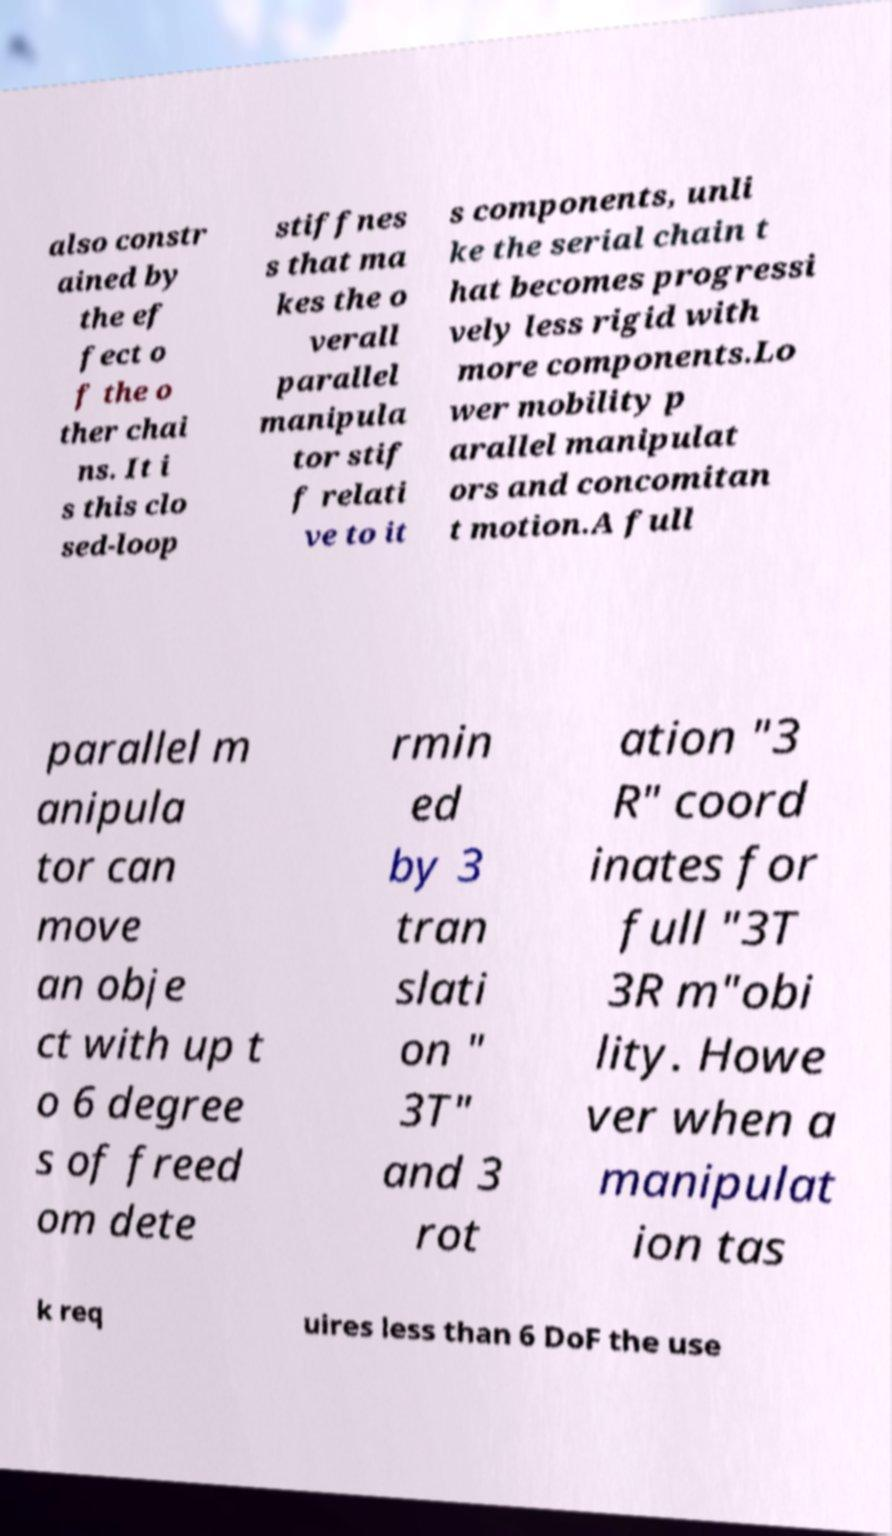Can you read and provide the text displayed in the image?This photo seems to have some interesting text. Can you extract and type it out for me? also constr ained by the ef fect o f the o ther chai ns. It i s this clo sed-loop stiffnes s that ma kes the o verall parallel manipula tor stif f relati ve to it s components, unli ke the serial chain t hat becomes progressi vely less rigid with more components.Lo wer mobility p arallel manipulat ors and concomitan t motion.A full parallel m anipula tor can move an obje ct with up t o 6 degree s of freed om dete rmin ed by 3 tran slati on " 3T" and 3 rot ation "3 R" coord inates for full "3T 3R m"obi lity. Howe ver when a manipulat ion tas k req uires less than 6 DoF the use 